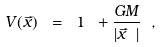Convert formula to latex. <formula><loc_0><loc_0><loc_500><loc_500>V ( \vec { x } ) \ = \ 1 \ + \frac { G M } { | \vec { x } \ | } \ ,</formula> 